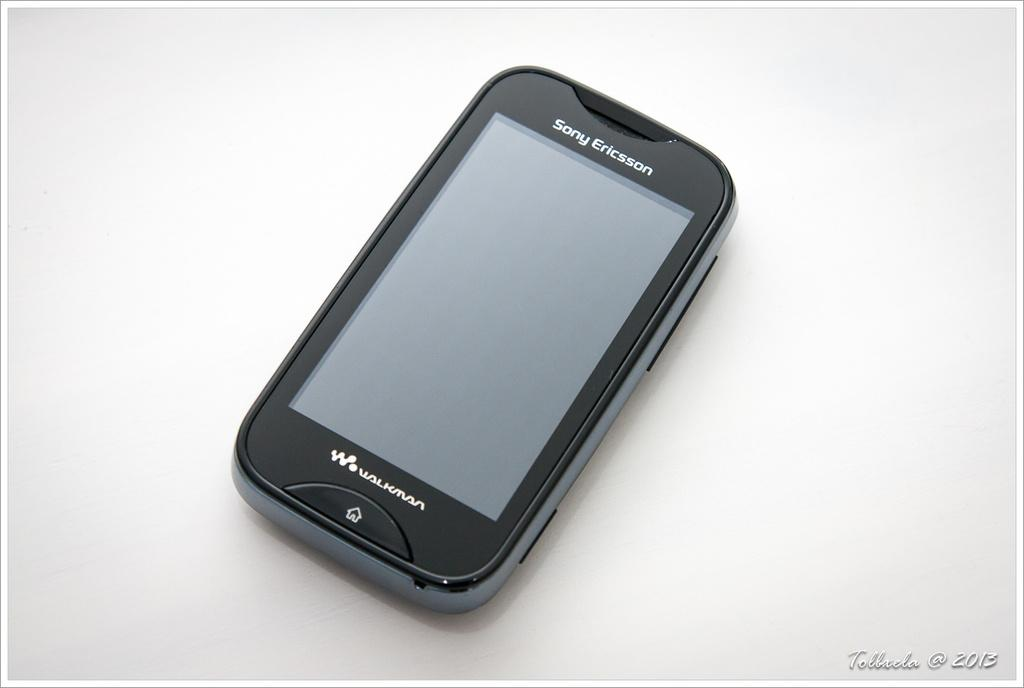<image>
Relay a brief, clear account of the picture shown. A Sony Ericsson smart phone against a white backdrop. 